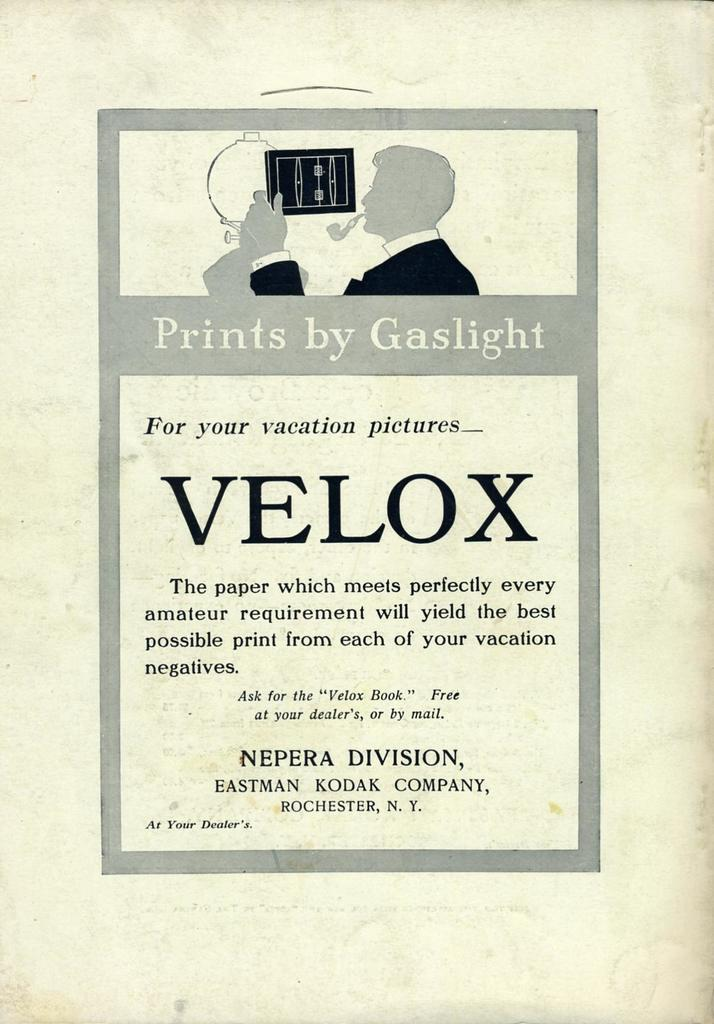What type of visual is the image? The image is a poster. What is shown on the poster? There is a depiction of a person on the poster. Are there any words on the poster? Yes, there is text on the poster. How many flowers are surrounding the person on the poster? There are no flowers present on the poster; it only features a depiction of a person and text. 